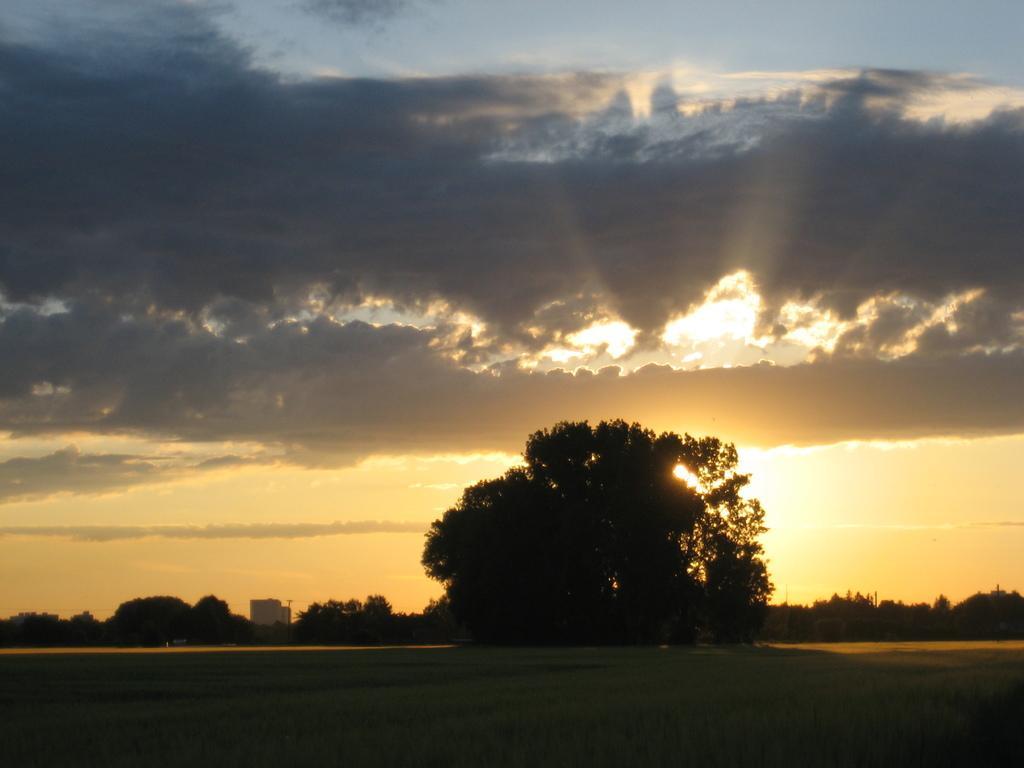Describe this image in one or two sentences. In this picture we can see the ground and in the background we can see trees and sky with clouds. 